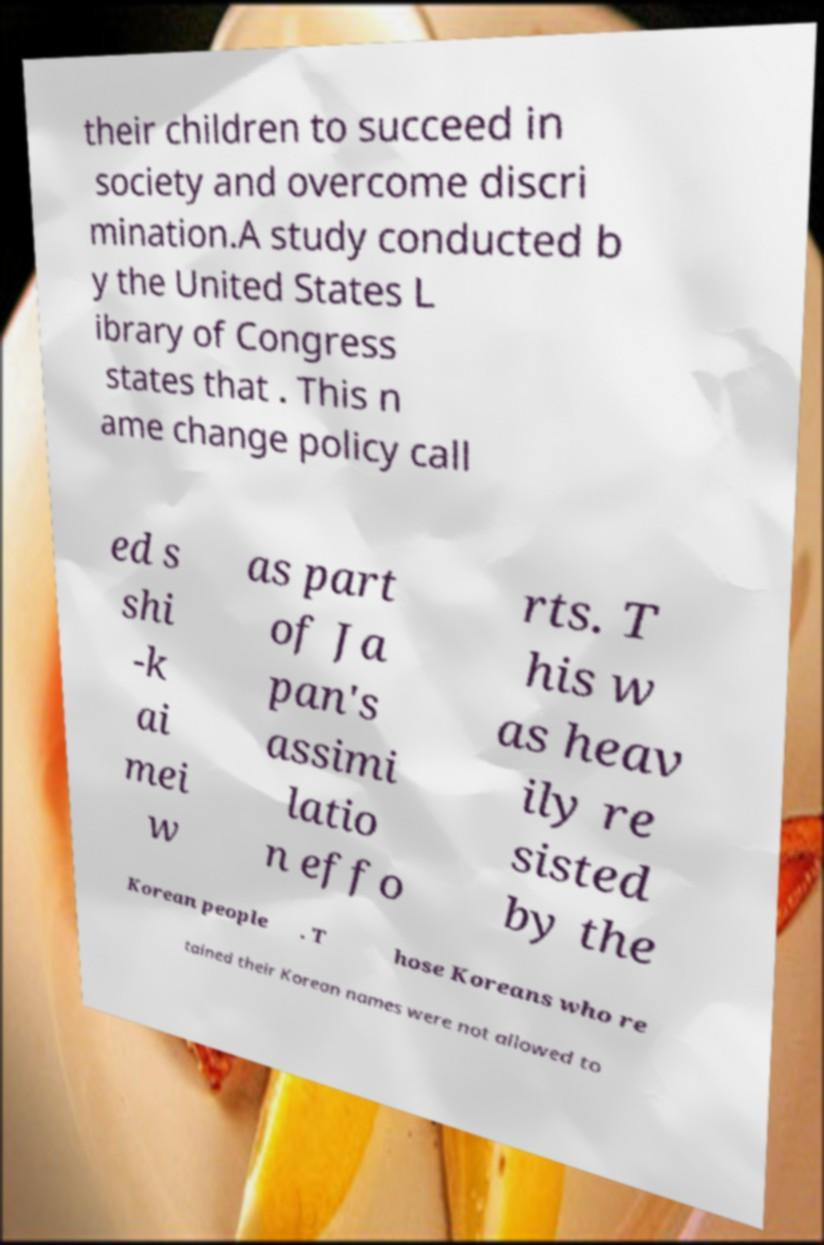Please read and relay the text visible in this image. What does it say? their children to succeed in society and overcome discri mination.A study conducted b y the United States L ibrary of Congress states that . This n ame change policy call ed s shi -k ai mei w as part of Ja pan's assimi latio n effo rts. T his w as heav ily re sisted by the Korean people . T hose Koreans who re tained their Korean names were not allowed to 